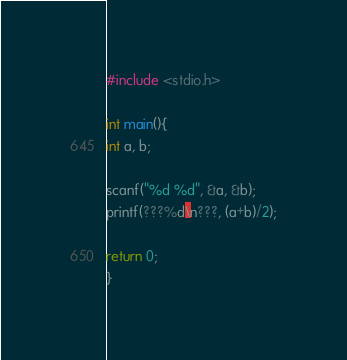Convert code to text. <code><loc_0><loc_0><loc_500><loc_500><_C_>#include <stdio.h>

int main(){
int a, b;

scanf("%d %d", &a, &b);
printf(???%d\n???, (a+b)/2);

return 0;
}</code> 